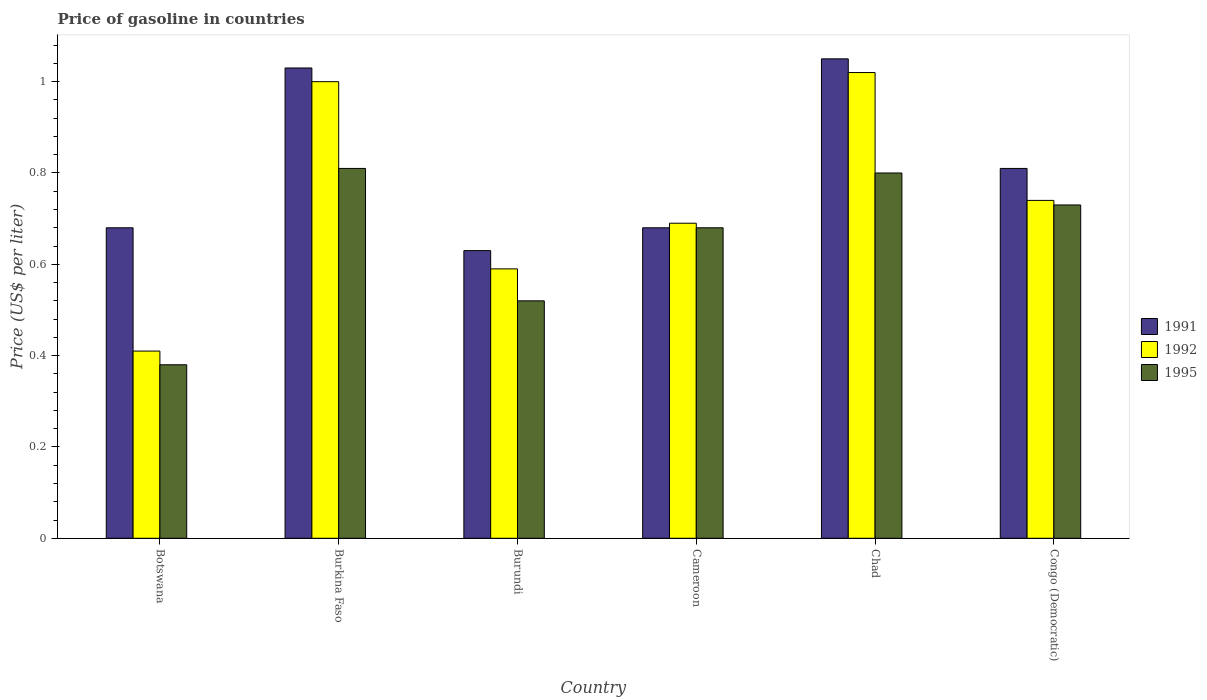How many different coloured bars are there?
Keep it short and to the point. 3. Are the number of bars per tick equal to the number of legend labels?
Your answer should be very brief. Yes. Are the number of bars on each tick of the X-axis equal?
Your response must be concise. Yes. How many bars are there on the 5th tick from the left?
Provide a succinct answer. 3. How many bars are there on the 3rd tick from the right?
Provide a succinct answer. 3. What is the label of the 6th group of bars from the left?
Keep it short and to the point. Congo (Democratic). Across all countries, what is the minimum price of gasoline in 1995?
Make the answer very short. 0.38. In which country was the price of gasoline in 1992 maximum?
Make the answer very short. Chad. In which country was the price of gasoline in 1995 minimum?
Offer a terse response. Botswana. What is the total price of gasoline in 1995 in the graph?
Your answer should be very brief. 3.92. What is the difference between the price of gasoline in 1992 in Burundi and that in Congo (Democratic)?
Your response must be concise. -0.15. What is the difference between the price of gasoline in 1995 in Burundi and the price of gasoline in 1992 in Congo (Democratic)?
Ensure brevity in your answer.  -0.22. What is the average price of gasoline in 1992 per country?
Offer a terse response. 0.74. What is the difference between the price of gasoline of/in 1991 and price of gasoline of/in 1992 in Burkina Faso?
Keep it short and to the point. 0.03. What is the ratio of the price of gasoline in 1992 in Burundi to that in Chad?
Ensure brevity in your answer.  0.58. What is the difference between the highest and the second highest price of gasoline in 1992?
Your answer should be very brief. -0.28. What is the difference between the highest and the lowest price of gasoline in 1992?
Provide a succinct answer. 0.61. Is the sum of the price of gasoline in 1991 in Chad and Congo (Democratic) greater than the maximum price of gasoline in 1995 across all countries?
Keep it short and to the point. Yes. What does the 2nd bar from the left in Botswana represents?
Your response must be concise. 1992. Is it the case that in every country, the sum of the price of gasoline in 1991 and price of gasoline in 1995 is greater than the price of gasoline in 1992?
Provide a short and direct response. Yes. How many bars are there?
Offer a very short reply. 18. Are the values on the major ticks of Y-axis written in scientific E-notation?
Offer a terse response. No. Where does the legend appear in the graph?
Ensure brevity in your answer.  Center right. How many legend labels are there?
Your answer should be compact. 3. What is the title of the graph?
Offer a terse response. Price of gasoline in countries. Does "1988" appear as one of the legend labels in the graph?
Keep it short and to the point. No. What is the label or title of the X-axis?
Ensure brevity in your answer.  Country. What is the label or title of the Y-axis?
Provide a short and direct response. Price (US$ per liter). What is the Price (US$ per liter) of 1991 in Botswana?
Your response must be concise. 0.68. What is the Price (US$ per liter) of 1992 in Botswana?
Make the answer very short. 0.41. What is the Price (US$ per liter) of 1995 in Botswana?
Keep it short and to the point. 0.38. What is the Price (US$ per liter) of 1991 in Burkina Faso?
Keep it short and to the point. 1.03. What is the Price (US$ per liter) of 1992 in Burkina Faso?
Ensure brevity in your answer.  1. What is the Price (US$ per liter) in 1995 in Burkina Faso?
Your answer should be compact. 0.81. What is the Price (US$ per liter) in 1991 in Burundi?
Your response must be concise. 0.63. What is the Price (US$ per liter) of 1992 in Burundi?
Your answer should be very brief. 0.59. What is the Price (US$ per liter) in 1995 in Burundi?
Give a very brief answer. 0.52. What is the Price (US$ per liter) in 1991 in Cameroon?
Ensure brevity in your answer.  0.68. What is the Price (US$ per liter) in 1992 in Cameroon?
Offer a very short reply. 0.69. What is the Price (US$ per liter) in 1995 in Cameroon?
Keep it short and to the point. 0.68. What is the Price (US$ per liter) in 1995 in Chad?
Offer a very short reply. 0.8. What is the Price (US$ per liter) in 1991 in Congo (Democratic)?
Provide a short and direct response. 0.81. What is the Price (US$ per liter) in 1992 in Congo (Democratic)?
Provide a succinct answer. 0.74. What is the Price (US$ per liter) in 1995 in Congo (Democratic)?
Your answer should be very brief. 0.73. Across all countries, what is the maximum Price (US$ per liter) in 1991?
Ensure brevity in your answer.  1.05. Across all countries, what is the maximum Price (US$ per liter) of 1992?
Ensure brevity in your answer.  1.02. Across all countries, what is the maximum Price (US$ per liter) in 1995?
Your response must be concise. 0.81. Across all countries, what is the minimum Price (US$ per liter) in 1991?
Provide a succinct answer. 0.63. Across all countries, what is the minimum Price (US$ per liter) in 1992?
Offer a terse response. 0.41. Across all countries, what is the minimum Price (US$ per liter) in 1995?
Keep it short and to the point. 0.38. What is the total Price (US$ per liter) in 1991 in the graph?
Ensure brevity in your answer.  4.88. What is the total Price (US$ per liter) of 1992 in the graph?
Ensure brevity in your answer.  4.45. What is the total Price (US$ per liter) in 1995 in the graph?
Provide a succinct answer. 3.92. What is the difference between the Price (US$ per liter) of 1991 in Botswana and that in Burkina Faso?
Offer a very short reply. -0.35. What is the difference between the Price (US$ per liter) of 1992 in Botswana and that in Burkina Faso?
Ensure brevity in your answer.  -0.59. What is the difference between the Price (US$ per liter) of 1995 in Botswana and that in Burkina Faso?
Offer a very short reply. -0.43. What is the difference between the Price (US$ per liter) in 1991 in Botswana and that in Burundi?
Your response must be concise. 0.05. What is the difference between the Price (US$ per liter) of 1992 in Botswana and that in Burundi?
Your answer should be very brief. -0.18. What is the difference between the Price (US$ per liter) of 1995 in Botswana and that in Burundi?
Give a very brief answer. -0.14. What is the difference between the Price (US$ per liter) in 1992 in Botswana and that in Cameroon?
Ensure brevity in your answer.  -0.28. What is the difference between the Price (US$ per liter) in 1995 in Botswana and that in Cameroon?
Make the answer very short. -0.3. What is the difference between the Price (US$ per liter) in 1991 in Botswana and that in Chad?
Make the answer very short. -0.37. What is the difference between the Price (US$ per liter) in 1992 in Botswana and that in Chad?
Provide a short and direct response. -0.61. What is the difference between the Price (US$ per liter) of 1995 in Botswana and that in Chad?
Your answer should be compact. -0.42. What is the difference between the Price (US$ per liter) of 1991 in Botswana and that in Congo (Democratic)?
Give a very brief answer. -0.13. What is the difference between the Price (US$ per liter) of 1992 in Botswana and that in Congo (Democratic)?
Your answer should be compact. -0.33. What is the difference between the Price (US$ per liter) in 1995 in Botswana and that in Congo (Democratic)?
Provide a short and direct response. -0.35. What is the difference between the Price (US$ per liter) of 1991 in Burkina Faso and that in Burundi?
Your response must be concise. 0.4. What is the difference between the Price (US$ per liter) in 1992 in Burkina Faso and that in Burundi?
Offer a terse response. 0.41. What is the difference between the Price (US$ per liter) of 1995 in Burkina Faso and that in Burundi?
Keep it short and to the point. 0.29. What is the difference between the Price (US$ per liter) of 1992 in Burkina Faso and that in Cameroon?
Offer a very short reply. 0.31. What is the difference between the Price (US$ per liter) of 1995 in Burkina Faso and that in Cameroon?
Provide a short and direct response. 0.13. What is the difference between the Price (US$ per liter) in 1991 in Burkina Faso and that in Chad?
Offer a terse response. -0.02. What is the difference between the Price (US$ per liter) in 1992 in Burkina Faso and that in Chad?
Make the answer very short. -0.02. What is the difference between the Price (US$ per liter) in 1991 in Burkina Faso and that in Congo (Democratic)?
Provide a short and direct response. 0.22. What is the difference between the Price (US$ per liter) of 1992 in Burkina Faso and that in Congo (Democratic)?
Provide a short and direct response. 0.26. What is the difference between the Price (US$ per liter) of 1991 in Burundi and that in Cameroon?
Offer a very short reply. -0.05. What is the difference between the Price (US$ per liter) in 1992 in Burundi and that in Cameroon?
Provide a short and direct response. -0.1. What is the difference between the Price (US$ per liter) in 1995 in Burundi and that in Cameroon?
Offer a terse response. -0.16. What is the difference between the Price (US$ per liter) in 1991 in Burundi and that in Chad?
Your answer should be compact. -0.42. What is the difference between the Price (US$ per liter) of 1992 in Burundi and that in Chad?
Give a very brief answer. -0.43. What is the difference between the Price (US$ per liter) of 1995 in Burundi and that in Chad?
Your response must be concise. -0.28. What is the difference between the Price (US$ per liter) in 1991 in Burundi and that in Congo (Democratic)?
Provide a short and direct response. -0.18. What is the difference between the Price (US$ per liter) of 1992 in Burundi and that in Congo (Democratic)?
Give a very brief answer. -0.15. What is the difference between the Price (US$ per liter) in 1995 in Burundi and that in Congo (Democratic)?
Your response must be concise. -0.21. What is the difference between the Price (US$ per liter) of 1991 in Cameroon and that in Chad?
Provide a succinct answer. -0.37. What is the difference between the Price (US$ per liter) in 1992 in Cameroon and that in Chad?
Ensure brevity in your answer.  -0.33. What is the difference between the Price (US$ per liter) in 1995 in Cameroon and that in Chad?
Your response must be concise. -0.12. What is the difference between the Price (US$ per liter) in 1991 in Cameroon and that in Congo (Democratic)?
Offer a very short reply. -0.13. What is the difference between the Price (US$ per liter) of 1995 in Cameroon and that in Congo (Democratic)?
Offer a terse response. -0.05. What is the difference between the Price (US$ per liter) of 1991 in Chad and that in Congo (Democratic)?
Give a very brief answer. 0.24. What is the difference between the Price (US$ per liter) of 1992 in Chad and that in Congo (Democratic)?
Offer a terse response. 0.28. What is the difference between the Price (US$ per liter) in 1995 in Chad and that in Congo (Democratic)?
Make the answer very short. 0.07. What is the difference between the Price (US$ per liter) of 1991 in Botswana and the Price (US$ per liter) of 1992 in Burkina Faso?
Ensure brevity in your answer.  -0.32. What is the difference between the Price (US$ per liter) of 1991 in Botswana and the Price (US$ per liter) of 1995 in Burkina Faso?
Make the answer very short. -0.13. What is the difference between the Price (US$ per liter) in 1991 in Botswana and the Price (US$ per liter) in 1992 in Burundi?
Provide a succinct answer. 0.09. What is the difference between the Price (US$ per liter) of 1991 in Botswana and the Price (US$ per liter) of 1995 in Burundi?
Offer a very short reply. 0.16. What is the difference between the Price (US$ per liter) of 1992 in Botswana and the Price (US$ per liter) of 1995 in Burundi?
Provide a succinct answer. -0.11. What is the difference between the Price (US$ per liter) in 1991 in Botswana and the Price (US$ per liter) in 1992 in Cameroon?
Provide a short and direct response. -0.01. What is the difference between the Price (US$ per liter) in 1991 in Botswana and the Price (US$ per liter) in 1995 in Cameroon?
Give a very brief answer. 0. What is the difference between the Price (US$ per liter) in 1992 in Botswana and the Price (US$ per liter) in 1995 in Cameroon?
Your answer should be compact. -0.27. What is the difference between the Price (US$ per liter) in 1991 in Botswana and the Price (US$ per liter) in 1992 in Chad?
Your response must be concise. -0.34. What is the difference between the Price (US$ per liter) of 1991 in Botswana and the Price (US$ per liter) of 1995 in Chad?
Make the answer very short. -0.12. What is the difference between the Price (US$ per liter) in 1992 in Botswana and the Price (US$ per liter) in 1995 in Chad?
Make the answer very short. -0.39. What is the difference between the Price (US$ per liter) in 1991 in Botswana and the Price (US$ per liter) in 1992 in Congo (Democratic)?
Ensure brevity in your answer.  -0.06. What is the difference between the Price (US$ per liter) of 1991 in Botswana and the Price (US$ per liter) of 1995 in Congo (Democratic)?
Your answer should be very brief. -0.05. What is the difference between the Price (US$ per liter) in 1992 in Botswana and the Price (US$ per liter) in 1995 in Congo (Democratic)?
Offer a terse response. -0.32. What is the difference between the Price (US$ per liter) in 1991 in Burkina Faso and the Price (US$ per liter) in 1992 in Burundi?
Offer a very short reply. 0.44. What is the difference between the Price (US$ per liter) of 1991 in Burkina Faso and the Price (US$ per liter) of 1995 in Burundi?
Ensure brevity in your answer.  0.51. What is the difference between the Price (US$ per liter) in 1992 in Burkina Faso and the Price (US$ per liter) in 1995 in Burundi?
Your answer should be very brief. 0.48. What is the difference between the Price (US$ per liter) of 1991 in Burkina Faso and the Price (US$ per liter) of 1992 in Cameroon?
Give a very brief answer. 0.34. What is the difference between the Price (US$ per liter) in 1991 in Burkina Faso and the Price (US$ per liter) in 1995 in Cameroon?
Provide a succinct answer. 0.35. What is the difference between the Price (US$ per liter) of 1992 in Burkina Faso and the Price (US$ per liter) of 1995 in Cameroon?
Your answer should be very brief. 0.32. What is the difference between the Price (US$ per liter) in 1991 in Burkina Faso and the Price (US$ per liter) in 1992 in Chad?
Give a very brief answer. 0.01. What is the difference between the Price (US$ per liter) of 1991 in Burkina Faso and the Price (US$ per liter) of 1995 in Chad?
Offer a very short reply. 0.23. What is the difference between the Price (US$ per liter) in 1992 in Burkina Faso and the Price (US$ per liter) in 1995 in Chad?
Your response must be concise. 0.2. What is the difference between the Price (US$ per liter) in 1991 in Burkina Faso and the Price (US$ per liter) in 1992 in Congo (Democratic)?
Your response must be concise. 0.29. What is the difference between the Price (US$ per liter) of 1991 in Burkina Faso and the Price (US$ per liter) of 1995 in Congo (Democratic)?
Provide a short and direct response. 0.3. What is the difference between the Price (US$ per liter) of 1992 in Burkina Faso and the Price (US$ per liter) of 1995 in Congo (Democratic)?
Ensure brevity in your answer.  0.27. What is the difference between the Price (US$ per liter) in 1991 in Burundi and the Price (US$ per liter) in 1992 in Cameroon?
Offer a terse response. -0.06. What is the difference between the Price (US$ per liter) in 1992 in Burundi and the Price (US$ per liter) in 1995 in Cameroon?
Ensure brevity in your answer.  -0.09. What is the difference between the Price (US$ per liter) in 1991 in Burundi and the Price (US$ per liter) in 1992 in Chad?
Offer a terse response. -0.39. What is the difference between the Price (US$ per liter) of 1991 in Burundi and the Price (US$ per liter) of 1995 in Chad?
Offer a terse response. -0.17. What is the difference between the Price (US$ per liter) in 1992 in Burundi and the Price (US$ per liter) in 1995 in Chad?
Make the answer very short. -0.21. What is the difference between the Price (US$ per liter) of 1991 in Burundi and the Price (US$ per liter) of 1992 in Congo (Democratic)?
Keep it short and to the point. -0.11. What is the difference between the Price (US$ per liter) in 1991 in Burundi and the Price (US$ per liter) in 1995 in Congo (Democratic)?
Make the answer very short. -0.1. What is the difference between the Price (US$ per liter) of 1992 in Burundi and the Price (US$ per liter) of 1995 in Congo (Democratic)?
Give a very brief answer. -0.14. What is the difference between the Price (US$ per liter) of 1991 in Cameroon and the Price (US$ per liter) of 1992 in Chad?
Your response must be concise. -0.34. What is the difference between the Price (US$ per liter) of 1991 in Cameroon and the Price (US$ per liter) of 1995 in Chad?
Give a very brief answer. -0.12. What is the difference between the Price (US$ per liter) of 1992 in Cameroon and the Price (US$ per liter) of 1995 in Chad?
Ensure brevity in your answer.  -0.11. What is the difference between the Price (US$ per liter) of 1991 in Cameroon and the Price (US$ per liter) of 1992 in Congo (Democratic)?
Offer a very short reply. -0.06. What is the difference between the Price (US$ per liter) of 1992 in Cameroon and the Price (US$ per liter) of 1995 in Congo (Democratic)?
Your answer should be very brief. -0.04. What is the difference between the Price (US$ per liter) in 1991 in Chad and the Price (US$ per liter) in 1992 in Congo (Democratic)?
Make the answer very short. 0.31. What is the difference between the Price (US$ per liter) of 1991 in Chad and the Price (US$ per liter) of 1995 in Congo (Democratic)?
Your answer should be compact. 0.32. What is the difference between the Price (US$ per liter) of 1992 in Chad and the Price (US$ per liter) of 1995 in Congo (Democratic)?
Keep it short and to the point. 0.29. What is the average Price (US$ per liter) of 1991 per country?
Your answer should be very brief. 0.81. What is the average Price (US$ per liter) in 1992 per country?
Offer a terse response. 0.74. What is the average Price (US$ per liter) of 1995 per country?
Your answer should be compact. 0.65. What is the difference between the Price (US$ per liter) in 1991 and Price (US$ per liter) in 1992 in Botswana?
Make the answer very short. 0.27. What is the difference between the Price (US$ per liter) in 1992 and Price (US$ per liter) in 1995 in Botswana?
Make the answer very short. 0.03. What is the difference between the Price (US$ per liter) in 1991 and Price (US$ per liter) in 1992 in Burkina Faso?
Your answer should be compact. 0.03. What is the difference between the Price (US$ per liter) in 1991 and Price (US$ per liter) in 1995 in Burkina Faso?
Offer a terse response. 0.22. What is the difference between the Price (US$ per liter) of 1992 and Price (US$ per liter) of 1995 in Burkina Faso?
Your answer should be very brief. 0.19. What is the difference between the Price (US$ per liter) of 1991 and Price (US$ per liter) of 1995 in Burundi?
Make the answer very short. 0.11. What is the difference between the Price (US$ per liter) of 1992 and Price (US$ per liter) of 1995 in Burundi?
Provide a short and direct response. 0.07. What is the difference between the Price (US$ per liter) in 1991 and Price (US$ per liter) in 1992 in Cameroon?
Keep it short and to the point. -0.01. What is the difference between the Price (US$ per liter) in 1992 and Price (US$ per liter) in 1995 in Cameroon?
Your response must be concise. 0.01. What is the difference between the Price (US$ per liter) of 1991 and Price (US$ per liter) of 1992 in Chad?
Your response must be concise. 0.03. What is the difference between the Price (US$ per liter) in 1992 and Price (US$ per liter) in 1995 in Chad?
Make the answer very short. 0.22. What is the difference between the Price (US$ per liter) in 1991 and Price (US$ per liter) in 1992 in Congo (Democratic)?
Provide a succinct answer. 0.07. What is the difference between the Price (US$ per liter) of 1992 and Price (US$ per liter) of 1995 in Congo (Democratic)?
Provide a succinct answer. 0.01. What is the ratio of the Price (US$ per liter) in 1991 in Botswana to that in Burkina Faso?
Your answer should be compact. 0.66. What is the ratio of the Price (US$ per liter) in 1992 in Botswana to that in Burkina Faso?
Ensure brevity in your answer.  0.41. What is the ratio of the Price (US$ per liter) of 1995 in Botswana to that in Burkina Faso?
Offer a terse response. 0.47. What is the ratio of the Price (US$ per liter) of 1991 in Botswana to that in Burundi?
Your answer should be very brief. 1.08. What is the ratio of the Price (US$ per liter) in 1992 in Botswana to that in Burundi?
Provide a short and direct response. 0.69. What is the ratio of the Price (US$ per liter) of 1995 in Botswana to that in Burundi?
Make the answer very short. 0.73. What is the ratio of the Price (US$ per liter) of 1992 in Botswana to that in Cameroon?
Offer a terse response. 0.59. What is the ratio of the Price (US$ per liter) of 1995 in Botswana to that in Cameroon?
Keep it short and to the point. 0.56. What is the ratio of the Price (US$ per liter) in 1991 in Botswana to that in Chad?
Give a very brief answer. 0.65. What is the ratio of the Price (US$ per liter) of 1992 in Botswana to that in Chad?
Provide a succinct answer. 0.4. What is the ratio of the Price (US$ per liter) in 1995 in Botswana to that in Chad?
Give a very brief answer. 0.47. What is the ratio of the Price (US$ per liter) in 1991 in Botswana to that in Congo (Democratic)?
Offer a very short reply. 0.84. What is the ratio of the Price (US$ per liter) of 1992 in Botswana to that in Congo (Democratic)?
Provide a short and direct response. 0.55. What is the ratio of the Price (US$ per liter) in 1995 in Botswana to that in Congo (Democratic)?
Your response must be concise. 0.52. What is the ratio of the Price (US$ per liter) of 1991 in Burkina Faso to that in Burundi?
Your answer should be very brief. 1.63. What is the ratio of the Price (US$ per liter) of 1992 in Burkina Faso to that in Burundi?
Your answer should be compact. 1.69. What is the ratio of the Price (US$ per liter) of 1995 in Burkina Faso to that in Burundi?
Ensure brevity in your answer.  1.56. What is the ratio of the Price (US$ per liter) in 1991 in Burkina Faso to that in Cameroon?
Your response must be concise. 1.51. What is the ratio of the Price (US$ per liter) in 1992 in Burkina Faso to that in Cameroon?
Provide a succinct answer. 1.45. What is the ratio of the Price (US$ per liter) in 1995 in Burkina Faso to that in Cameroon?
Your answer should be compact. 1.19. What is the ratio of the Price (US$ per liter) in 1991 in Burkina Faso to that in Chad?
Ensure brevity in your answer.  0.98. What is the ratio of the Price (US$ per liter) in 1992 in Burkina Faso to that in Chad?
Offer a terse response. 0.98. What is the ratio of the Price (US$ per liter) of 1995 in Burkina Faso to that in Chad?
Your answer should be compact. 1.01. What is the ratio of the Price (US$ per liter) of 1991 in Burkina Faso to that in Congo (Democratic)?
Your answer should be compact. 1.27. What is the ratio of the Price (US$ per liter) of 1992 in Burkina Faso to that in Congo (Democratic)?
Keep it short and to the point. 1.35. What is the ratio of the Price (US$ per liter) in 1995 in Burkina Faso to that in Congo (Democratic)?
Offer a terse response. 1.11. What is the ratio of the Price (US$ per liter) in 1991 in Burundi to that in Cameroon?
Your answer should be very brief. 0.93. What is the ratio of the Price (US$ per liter) of 1992 in Burundi to that in Cameroon?
Offer a terse response. 0.86. What is the ratio of the Price (US$ per liter) of 1995 in Burundi to that in Cameroon?
Your response must be concise. 0.76. What is the ratio of the Price (US$ per liter) in 1992 in Burundi to that in Chad?
Keep it short and to the point. 0.58. What is the ratio of the Price (US$ per liter) of 1995 in Burundi to that in Chad?
Provide a succinct answer. 0.65. What is the ratio of the Price (US$ per liter) of 1991 in Burundi to that in Congo (Democratic)?
Provide a succinct answer. 0.78. What is the ratio of the Price (US$ per liter) in 1992 in Burundi to that in Congo (Democratic)?
Provide a succinct answer. 0.8. What is the ratio of the Price (US$ per liter) in 1995 in Burundi to that in Congo (Democratic)?
Ensure brevity in your answer.  0.71. What is the ratio of the Price (US$ per liter) in 1991 in Cameroon to that in Chad?
Provide a succinct answer. 0.65. What is the ratio of the Price (US$ per liter) in 1992 in Cameroon to that in Chad?
Your answer should be compact. 0.68. What is the ratio of the Price (US$ per liter) of 1991 in Cameroon to that in Congo (Democratic)?
Offer a terse response. 0.84. What is the ratio of the Price (US$ per liter) in 1992 in Cameroon to that in Congo (Democratic)?
Keep it short and to the point. 0.93. What is the ratio of the Price (US$ per liter) in 1995 in Cameroon to that in Congo (Democratic)?
Keep it short and to the point. 0.93. What is the ratio of the Price (US$ per liter) in 1991 in Chad to that in Congo (Democratic)?
Keep it short and to the point. 1.3. What is the ratio of the Price (US$ per liter) in 1992 in Chad to that in Congo (Democratic)?
Provide a short and direct response. 1.38. What is the ratio of the Price (US$ per liter) of 1995 in Chad to that in Congo (Democratic)?
Ensure brevity in your answer.  1.1. What is the difference between the highest and the second highest Price (US$ per liter) in 1991?
Provide a short and direct response. 0.02. What is the difference between the highest and the second highest Price (US$ per liter) in 1995?
Provide a short and direct response. 0.01. What is the difference between the highest and the lowest Price (US$ per liter) in 1991?
Give a very brief answer. 0.42. What is the difference between the highest and the lowest Price (US$ per liter) in 1992?
Your response must be concise. 0.61. What is the difference between the highest and the lowest Price (US$ per liter) of 1995?
Your response must be concise. 0.43. 